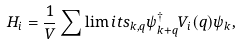Convert formula to latex. <formula><loc_0><loc_0><loc_500><loc_500>H _ { i } = \frac { 1 } { V } \sum \lim i t s _ { k , q } \psi _ { k + q } ^ { \dag } V _ { i } ( q ) \psi _ { k } ,</formula> 